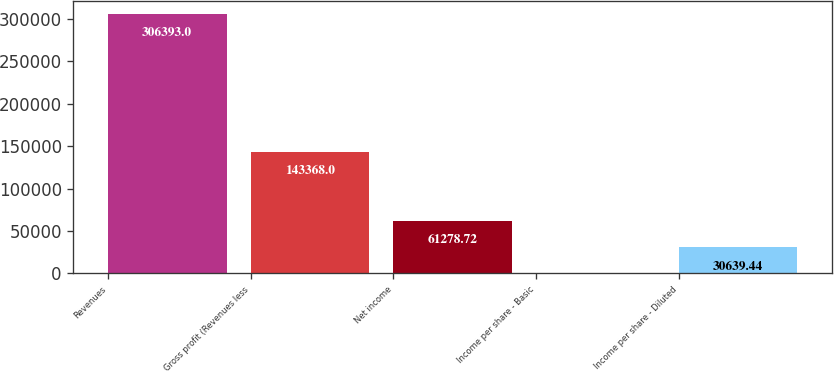Convert chart to OTSL. <chart><loc_0><loc_0><loc_500><loc_500><bar_chart><fcel>Revenues<fcel>Gross profit (Revenues less<fcel>Net income<fcel>Income per share - Basic<fcel>Income per share - Diluted<nl><fcel>306393<fcel>143368<fcel>61278.7<fcel>0.16<fcel>30639.4<nl></chart> 